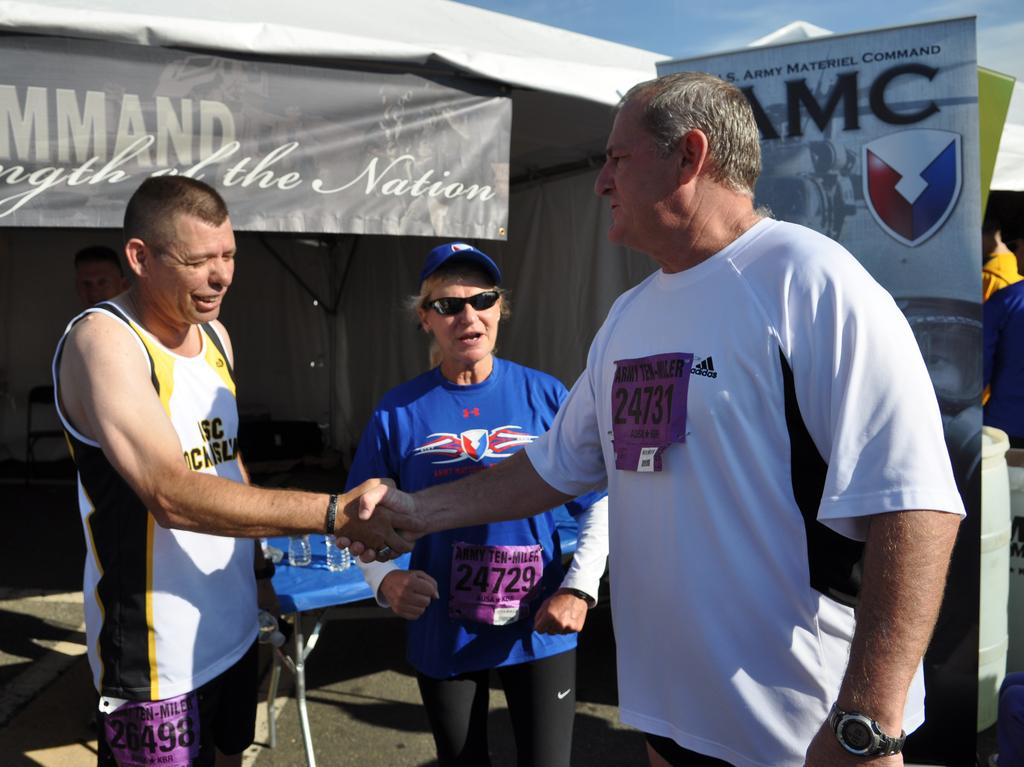Provide a one-sentence caption for the provided image. Two men shake hands while talking to a woman with a sign for U.S. Army Materiel Command. 